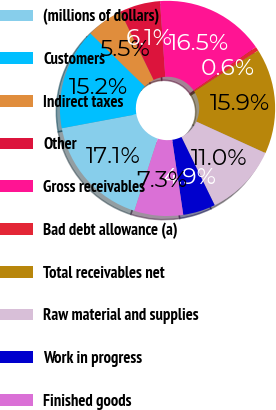Convert chart. <chart><loc_0><loc_0><loc_500><loc_500><pie_chart><fcel>(millions of dollars)<fcel>Customers<fcel>Indirect taxes<fcel>Other<fcel>Gross receivables<fcel>Bad debt allowance (a)<fcel>Total receivables net<fcel>Raw material and supplies<fcel>Work in progress<fcel>Finished goods<nl><fcel>17.07%<fcel>15.24%<fcel>5.49%<fcel>6.1%<fcel>16.46%<fcel>0.61%<fcel>15.85%<fcel>10.98%<fcel>4.88%<fcel>7.32%<nl></chart> 